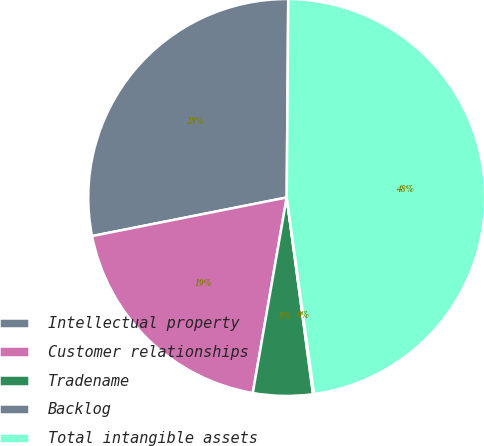Convert chart. <chart><loc_0><loc_0><loc_500><loc_500><pie_chart><fcel>Intellectual property<fcel>Customer relationships<fcel>Tradename<fcel>Backlog<fcel>Total intangible assets<nl><fcel>28.24%<fcel>19.15%<fcel>4.85%<fcel>0.09%<fcel>47.67%<nl></chart> 